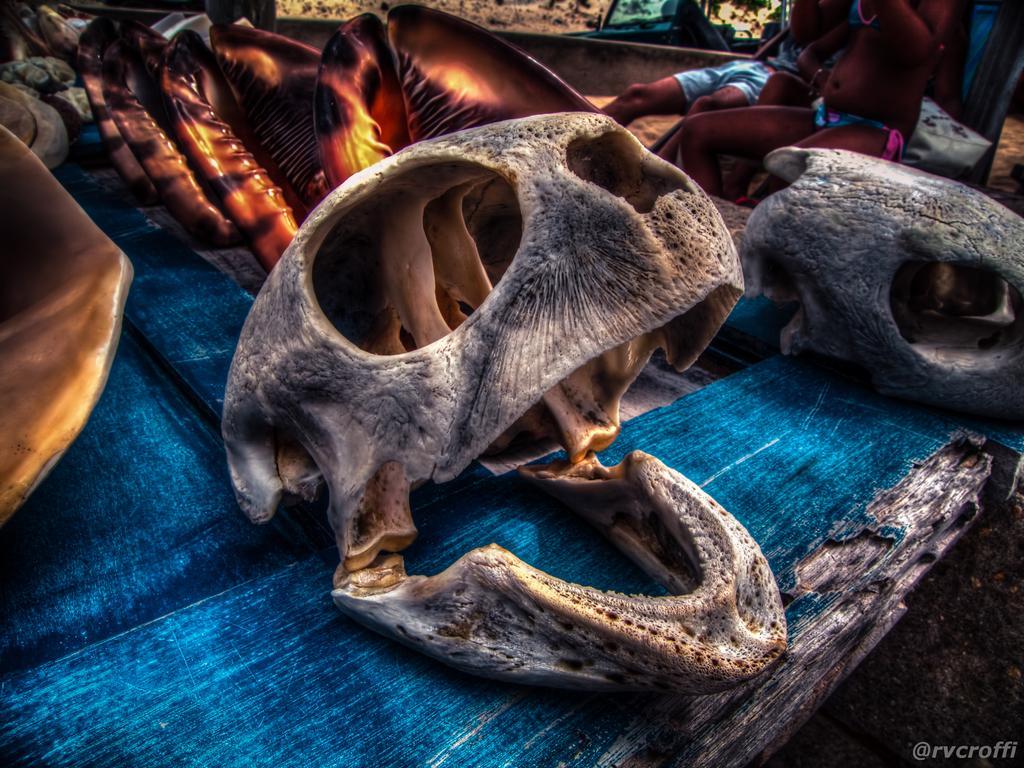Could you give a brief overview of what you see in this image? In this image, we can see skull of an animal and there are some people sitting in the background. 